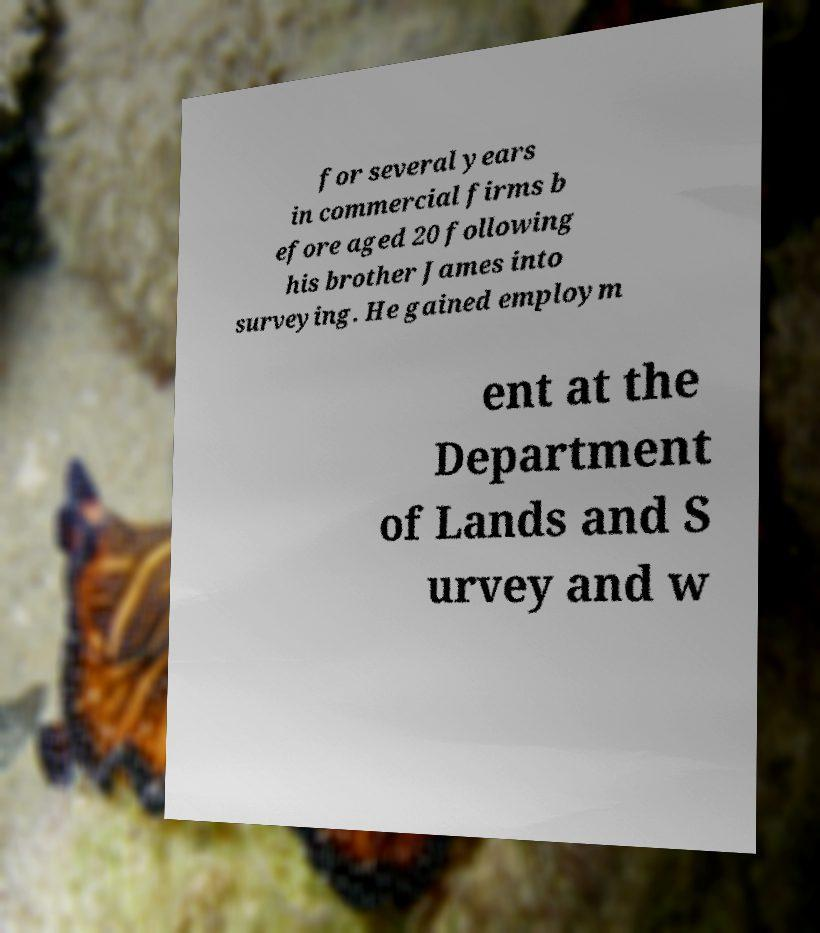I need the written content from this picture converted into text. Can you do that? for several years in commercial firms b efore aged 20 following his brother James into surveying. He gained employm ent at the Department of Lands and S urvey and w 